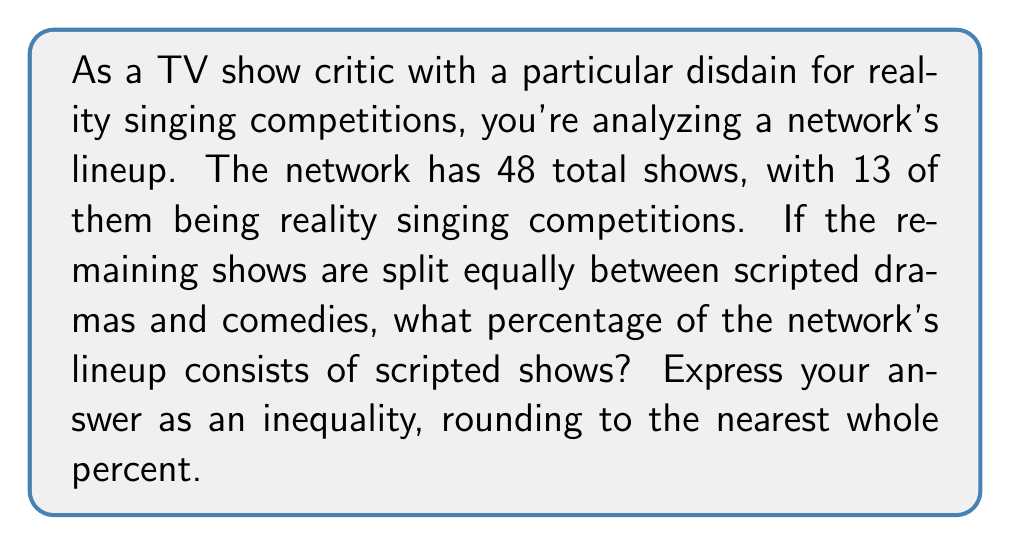Can you answer this question? Let's approach this step-by-step:

1) First, let's calculate the total number of non-singing competition shows:
   $48 - 13 = 35$ shows

2) We're told that the remaining shows are split equally between dramas and comedies. So:
   Number of dramas = Number of comedies = $35 \div 2 = 17.5$

3) Since we can't have half a show, we know that one category has 17 shows and the other has 18. This gives us a range for scripted shows:
   $17 + 17 = 34$ (minimum)
   $18 + 18 = 36$ (maximum)

4) To calculate the percentage, we use the formula:
   $\text{Percentage} = \frac{\text{Number of scripted shows}}{\text{Total number of shows}} \times 100\%$

5) For the minimum:
   $\frac{34}{48} \times 100\% \approx 70.83\%$

6) For the maximum:
   $\frac{36}{48} \times 100\% = 75\%$

7) Rounding to the nearest whole percent:
   $70.83\%$ rounds to $71\%$
   $75\%$ stays at $75\%$

Therefore, the percentage of scripted shows falls between 71% and 75%, inclusive.
Answer: $71\% \leq x \leq 75\%$, where $x$ is the percentage of scripted shows in the network's lineup. 